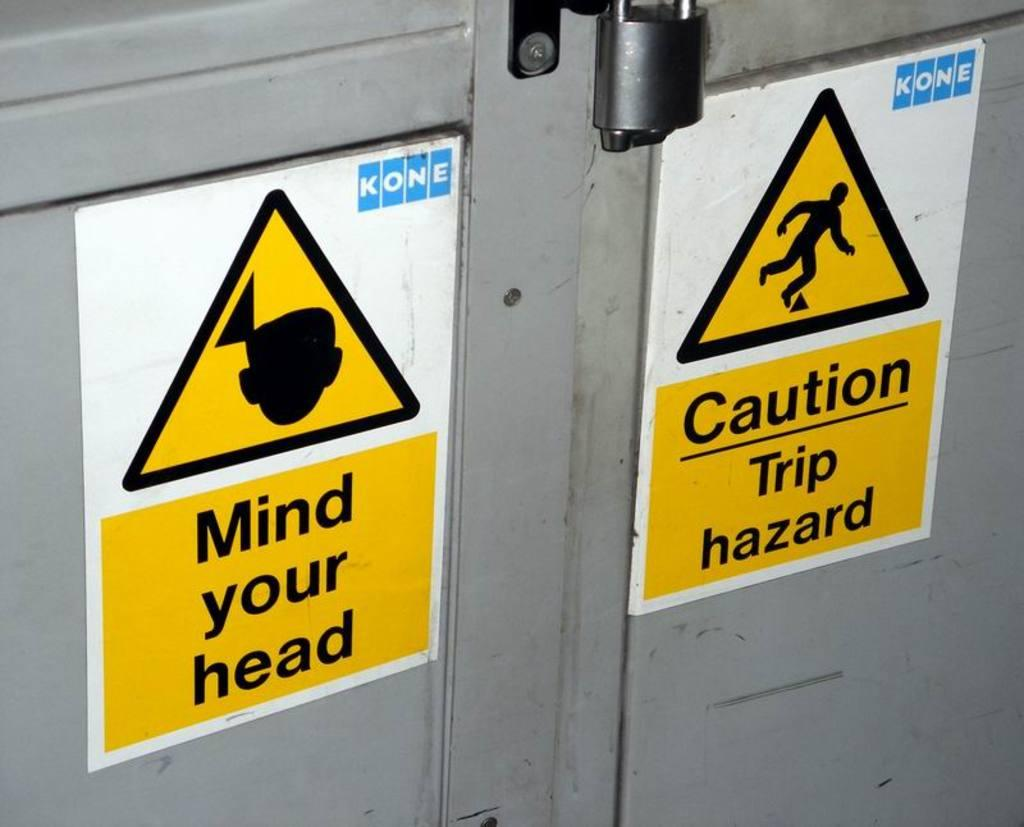Provide a one-sentence caption for the provided image. Two signs on a door warning people of potential hazards. 